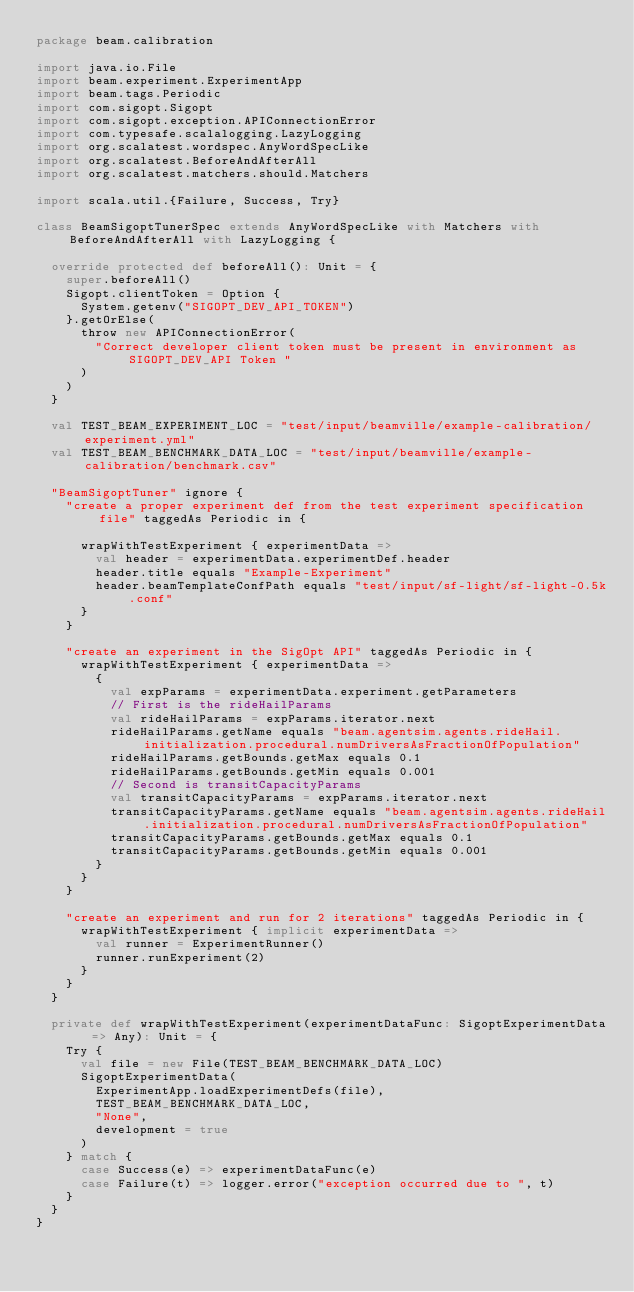Convert code to text. <code><loc_0><loc_0><loc_500><loc_500><_Scala_>package beam.calibration

import java.io.File
import beam.experiment.ExperimentApp
import beam.tags.Periodic
import com.sigopt.Sigopt
import com.sigopt.exception.APIConnectionError
import com.typesafe.scalalogging.LazyLogging
import org.scalatest.wordspec.AnyWordSpecLike
import org.scalatest.BeforeAndAfterAll
import org.scalatest.matchers.should.Matchers

import scala.util.{Failure, Success, Try}

class BeamSigoptTunerSpec extends AnyWordSpecLike with Matchers with BeforeAndAfterAll with LazyLogging {

  override protected def beforeAll(): Unit = {
    super.beforeAll()
    Sigopt.clientToken = Option {
      System.getenv("SIGOPT_DEV_API_TOKEN")
    }.getOrElse(
      throw new APIConnectionError(
        "Correct developer client token must be present in environment as SIGOPT_DEV_API Token "
      )
    )
  }

  val TEST_BEAM_EXPERIMENT_LOC = "test/input/beamville/example-calibration/experiment.yml"
  val TEST_BEAM_BENCHMARK_DATA_LOC = "test/input/beamville/example-calibration/benchmark.csv"

  "BeamSigoptTuner" ignore {
    "create a proper experiment def from the test experiment specification file" taggedAs Periodic in {

      wrapWithTestExperiment { experimentData =>
        val header = experimentData.experimentDef.header
        header.title equals "Example-Experiment"
        header.beamTemplateConfPath equals "test/input/sf-light/sf-light-0.5k.conf"
      }
    }

    "create an experiment in the SigOpt API" taggedAs Periodic in {
      wrapWithTestExperiment { experimentData =>
        {
          val expParams = experimentData.experiment.getParameters
          // First is the rideHailParams
          val rideHailParams = expParams.iterator.next
          rideHailParams.getName equals "beam.agentsim.agents.rideHail.initialization.procedural.numDriversAsFractionOfPopulation"
          rideHailParams.getBounds.getMax equals 0.1
          rideHailParams.getBounds.getMin equals 0.001
          // Second is transitCapacityParams
          val transitCapacityParams = expParams.iterator.next
          transitCapacityParams.getName equals "beam.agentsim.agents.rideHail.initialization.procedural.numDriversAsFractionOfPopulation"
          transitCapacityParams.getBounds.getMax equals 0.1
          transitCapacityParams.getBounds.getMin equals 0.001
        }
      }
    }

    "create an experiment and run for 2 iterations" taggedAs Periodic in {
      wrapWithTestExperiment { implicit experimentData =>
        val runner = ExperimentRunner()
        runner.runExperiment(2)
      }
    }
  }

  private def wrapWithTestExperiment(experimentDataFunc: SigoptExperimentData => Any): Unit = {
    Try {
      val file = new File(TEST_BEAM_BENCHMARK_DATA_LOC)
      SigoptExperimentData(
        ExperimentApp.loadExperimentDefs(file),
        TEST_BEAM_BENCHMARK_DATA_LOC,
        "None",
        development = true
      )
    } match {
      case Success(e) => experimentDataFunc(e)
      case Failure(t) => logger.error("exception occurred due to ", t)
    }
  }
}
</code> 